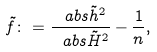Convert formula to latex. <formula><loc_0><loc_0><loc_500><loc_500>\tilde { f } \colon = \frac { \ a b s { \tilde { h } } ^ { 2 } } { \ a b s { \tilde { H } } ^ { 2 } } - \frac { 1 } { n } ,</formula> 